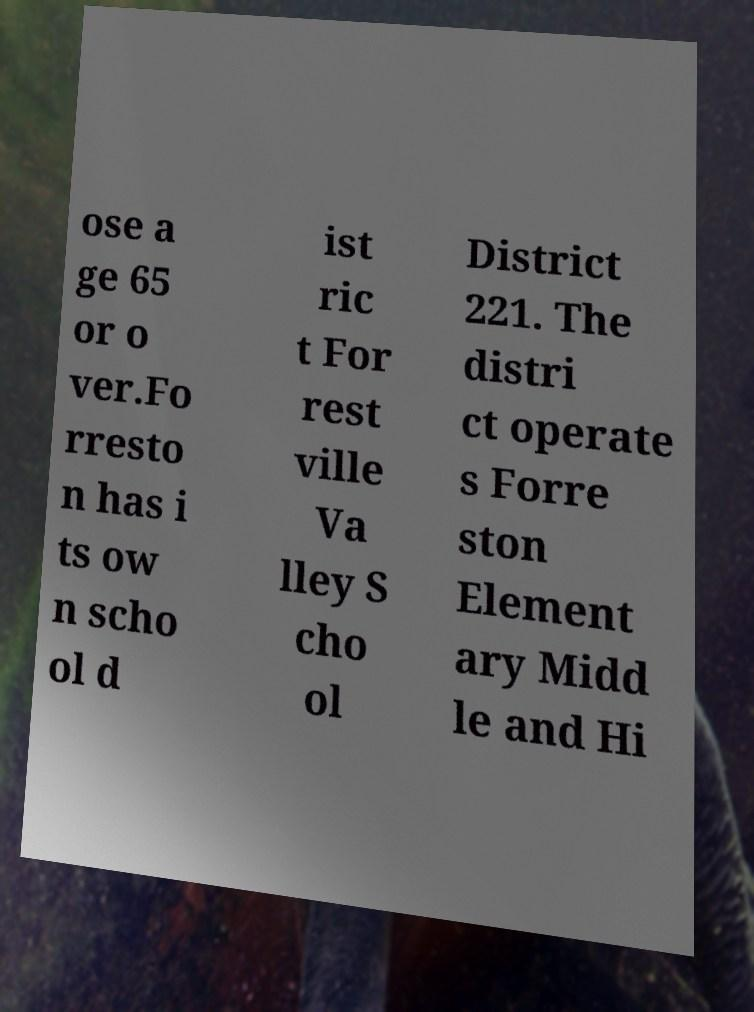Could you extract and type out the text from this image? ose a ge 65 or o ver.Fo rresto n has i ts ow n scho ol d ist ric t For rest ville Va lley S cho ol District 221. The distri ct operate s Forre ston Element ary Midd le and Hi 